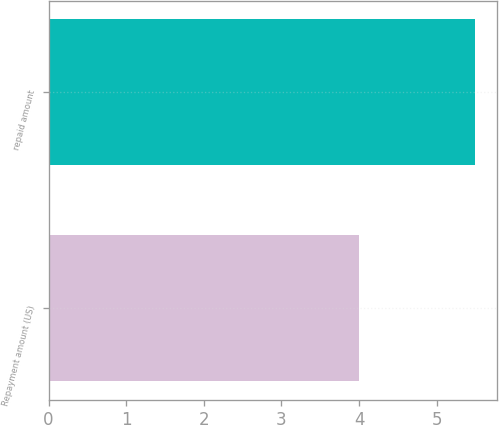Convert chart to OTSL. <chart><loc_0><loc_0><loc_500><loc_500><bar_chart><fcel>Repayment amount (US)<fcel>repaid amount<nl><fcel>4<fcel>5.5<nl></chart> 